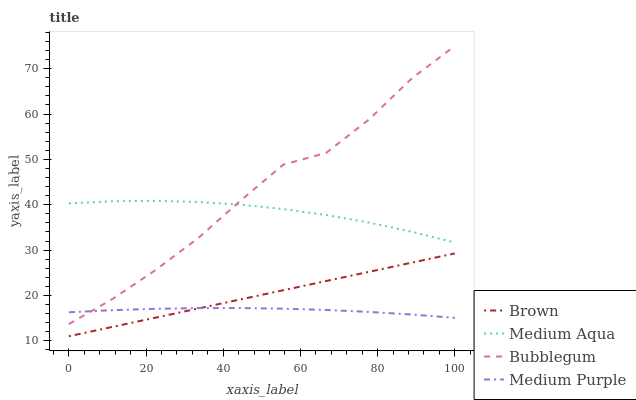Does Medium Purple have the minimum area under the curve?
Answer yes or no. Yes. Does Bubblegum have the maximum area under the curve?
Answer yes or no. Yes. Does Brown have the minimum area under the curve?
Answer yes or no. No. Does Brown have the maximum area under the curve?
Answer yes or no. No. Is Brown the smoothest?
Answer yes or no. Yes. Is Bubblegum the roughest?
Answer yes or no. Yes. Is Medium Aqua the smoothest?
Answer yes or no. No. Is Medium Aqua the roughest?
Answer yes or no. No. Does Medium Aqua have the lowest value?
Answer yes or no. No. Does Brown have the highest value?
Answer yes or no. No. Is Brown less than Medium Aqua?
Answer yes or no. Yes. Is Bubblegum greater than Brown?
Answer yes or no. Yes. Does Brown intersect Medium Aqua?
Answer yes or no. No. 